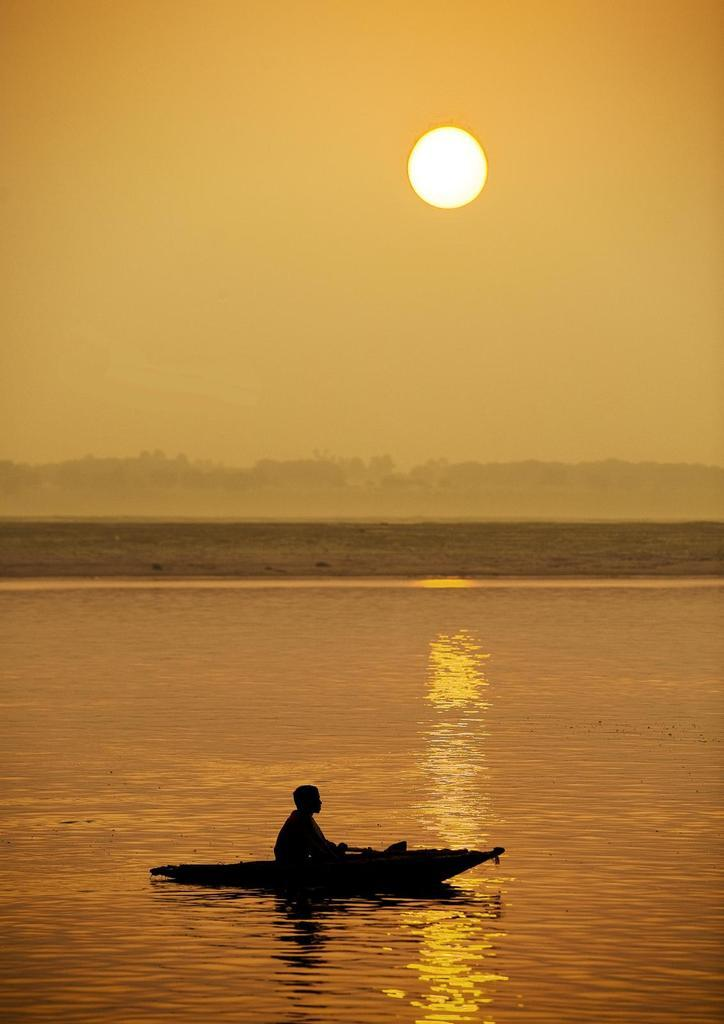Who is the main subject in the image? There is a boy in the image. What is the boy doing in the image? The boy is sitting on a boat. Where is the boat located in the image? The boat is placed in the water. What can be seen in the background of the image? There are mountains visible in the background of the image. What is the condition of the sky in the image? The sun is observable in the sky. What type of jewel is the boy holding in the image? There is no jewel present in the image; the boy is sitting on a boat in the water. How many legs does the boat have in the image? The boat does not have legs; it is floating on the water. 